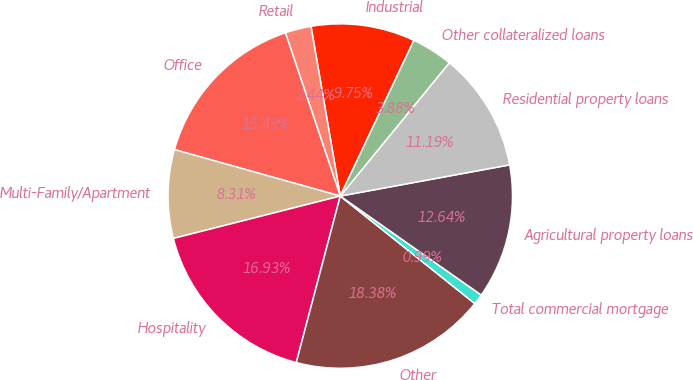Convert chart to OTSL. <chart><loc_0><loc_0><loc_500><loc_500><pie_chart><fcel>Industrial<fcel>Retail<fcel>Office<fcel>Multi-Family/Apartment<fcel>Hospitality<fcel>Other<fcel>Total commercial mortgage<fcel>Agricultural property loans<fcel>Residential property loans<fcel>Other collateralized loans<nl><fcel>9.75%<fcel>2.44%<fcel>15.49%<fcel>8.31%<fcel>16.93%<fcel>18.38%<fcel>0.99%<fcel>12.64%<fcel>11.19%<fcel>3.88%<nl></chart> 